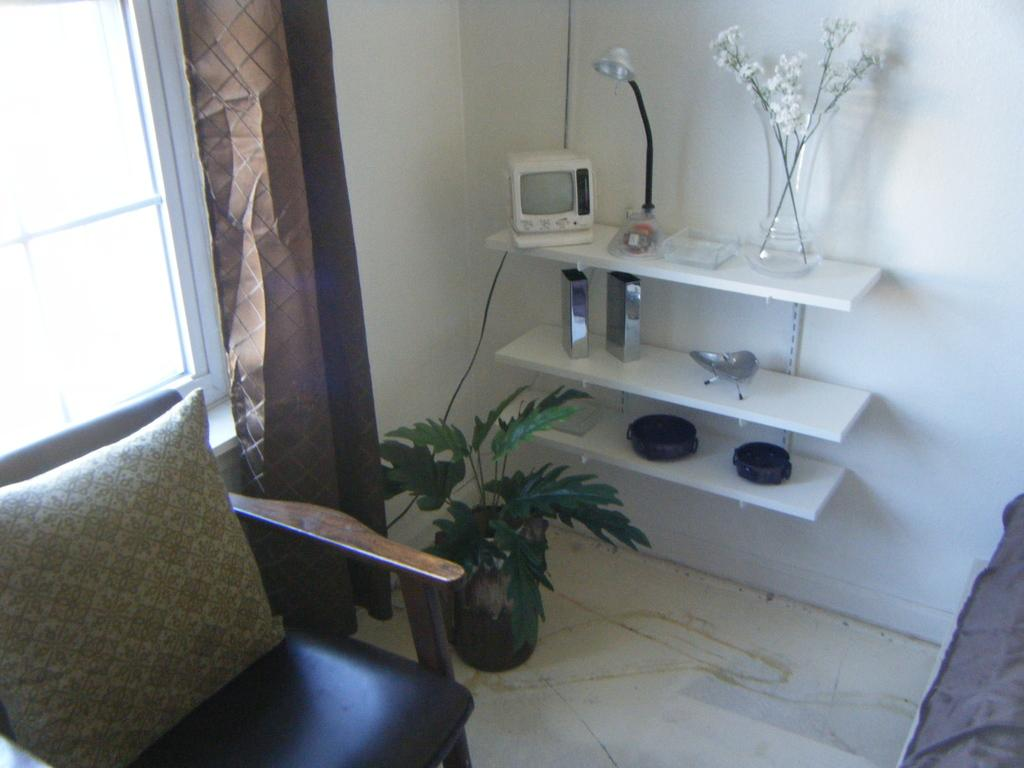What can be seen in the image that allows light to enter the room? There is a window in the image that allows light to enter the room. What is used to cover the window in the image? There is a curtain in the image that covers the window. What type of furniture is present in the image? There is a chair in the image. What type of accessory is present in the image that might be used for comfort? There is a pillow in the image that might be used for comfort. What type of living organism is present in the image? There is a plant in the image. What type of container is present in the image that might hold flowers? There is a flower vase in the image that might hold flowers. What type of lighting fixture is present in the image? There is a lamp in the image. What other items can be seen on the racks in the image? There are other items on the racks in the image, but their specific nature cannot be determined from the provided facts. Can you hear the sound of the pear falling from the tree in the image? There is no pear or tree present in the image, so it is not possible to hear any sounds related to them. 